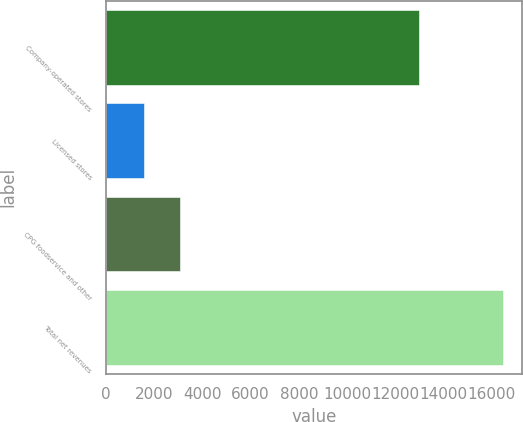<chart> <loc_0><loc_0><loc_500><loc_500><bar_chart><fcel>Company-operated stores<fcel>Licensed stores<fcel>CPG foodservice and other<fcel>Total net revenues<nl><fcel>12977.9<fcel>1588.6<fcel>3074.52<fcel>16447.8<nl></chart> 